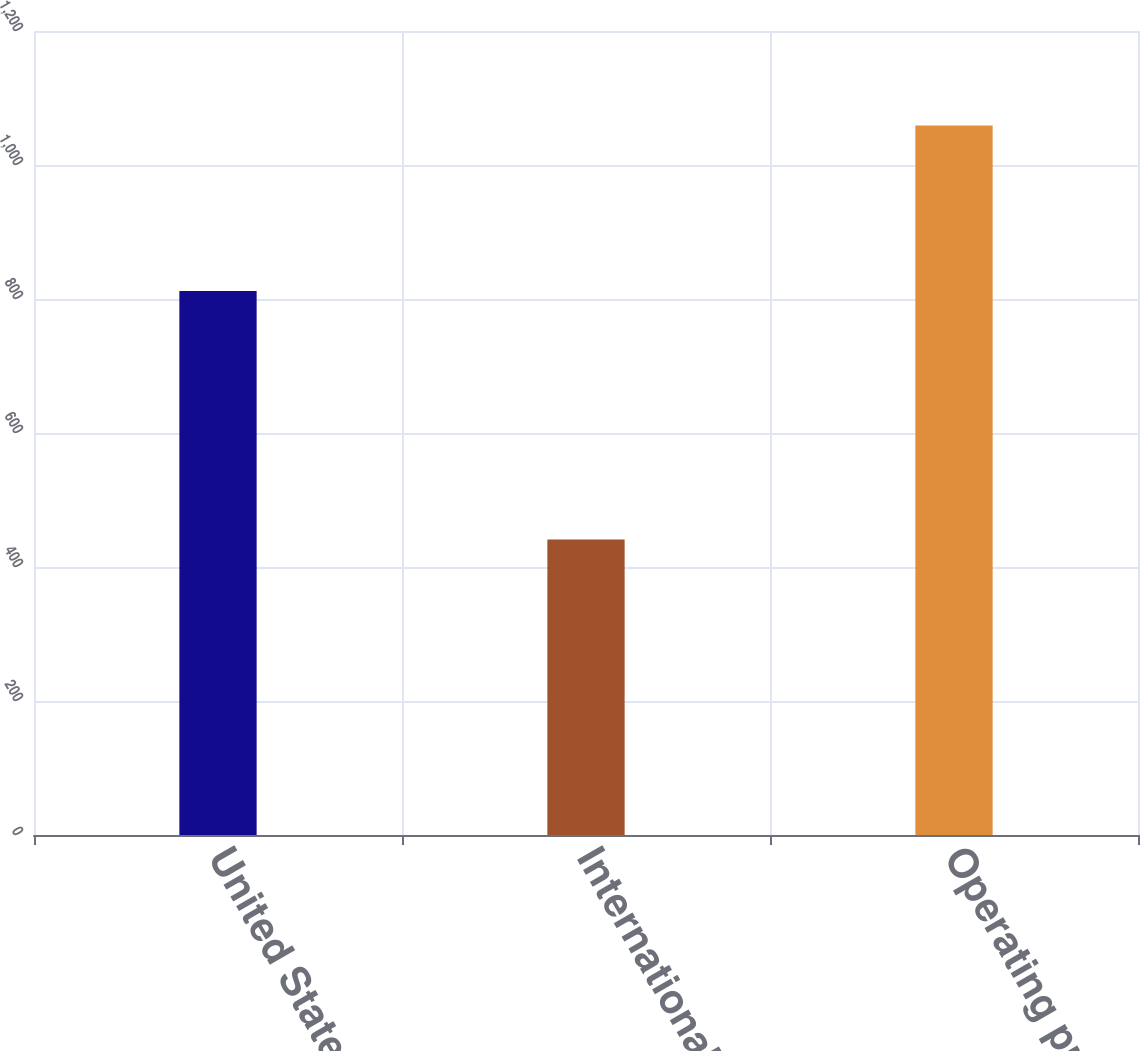Convert chart to OTSL. <chart><loc_0><loc_0><loc_500><loc_500><bar_chart><fcel>United States<fcel>International<fcel>Operating profit<nl><fcel>812<fcel>441<fcel>1059<nl></chart> 